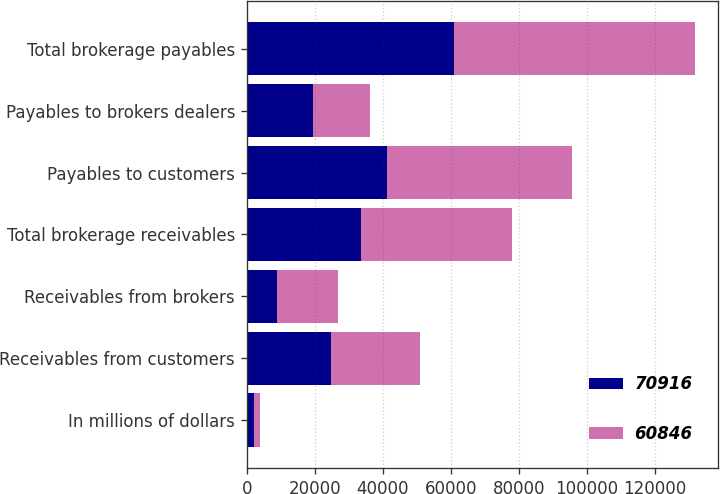Convert chart. <chart><loc_0><loc_0><loc_500><loc_500><stacked_bar_chart><ecel><fcel>In millions of dollars<fcel>Receivables from customers<fcel>Receivables from brokers<fcel>Total brokerage receivables<fcel>Payables to customers<fcel>Payables to brokers dealers<fcel>Total brokerage payables<nl><fcel>70916<fcel>2009<fcel>24721<fcel>8913<fcel>33634<fcel>41262<fcel>19584<fcel>60846<nl><fcel>60846<fcel>2008<fcel>26297<fcel>17981<fcel>44278<fcel>54167<fcel>16749<fcel>70916<nl></chart> 